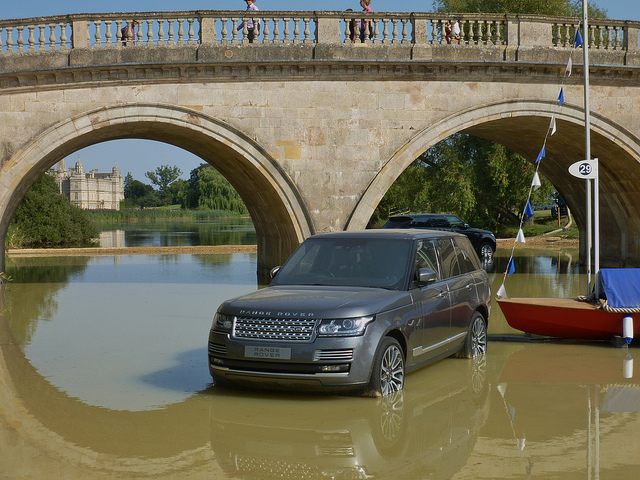Read and extract the text from this image. ROVER 29 